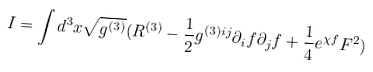<formula> <loc_0><loc_0><loc_500><loc_500>I = \int d ^ { 3 } x \sqrt { g ^ { ( 3 ) } } ( R ^ { ( 3 ) } - \frac { 1 } { 2 } g ^ { ( 3 ) i j } \partial _ { i } f \partial _ { j } f + \frac { 1 } { 4 } e ^ { \chi f } F ^ { 2 } )</formula> 